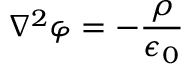<formula> <loc_0><loc_0><loc_500><loc_500>\nabla ^ { 2 } \varphi = - { \frac { \rho } { \epsilon _ { 0 } } }</formula> 